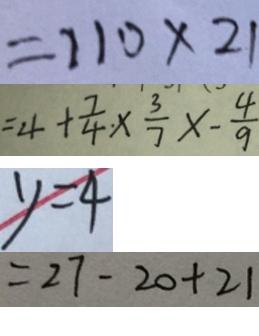<formula> <loc_0><loc_0><loc_500><loc_500>= 1 1 0 \times 2 1 
 = 4 + \frac { 7 } { 4 } \times \frac { 3 } { 7 } \times - \frac { 4 } { 9 } 
 y = 4 
 = 2 7 - 2 0 + 2 1</formula> 